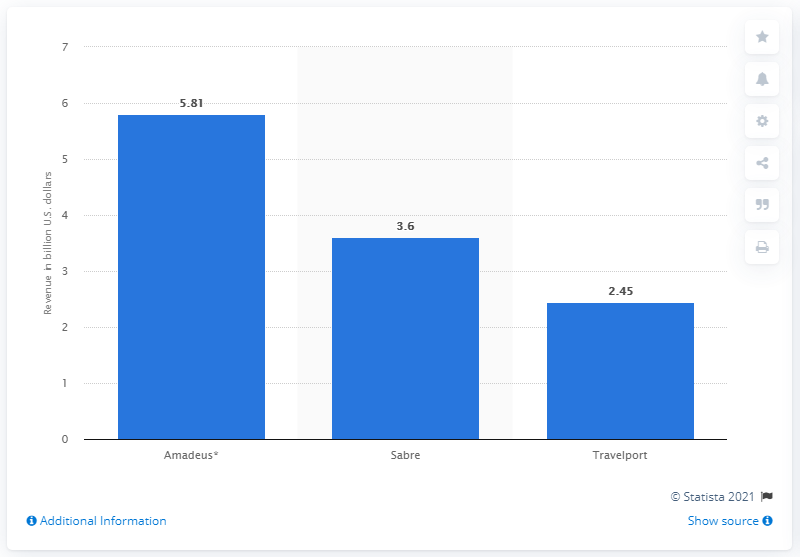Outline some significant characteristics in this image. Sabre's distribution system has experienced a significant increase in revenue over the past four years, making it one of the most successful distribution systems in the industry. Amadeus generated revenue of 5.81 billion euros in 2017. 